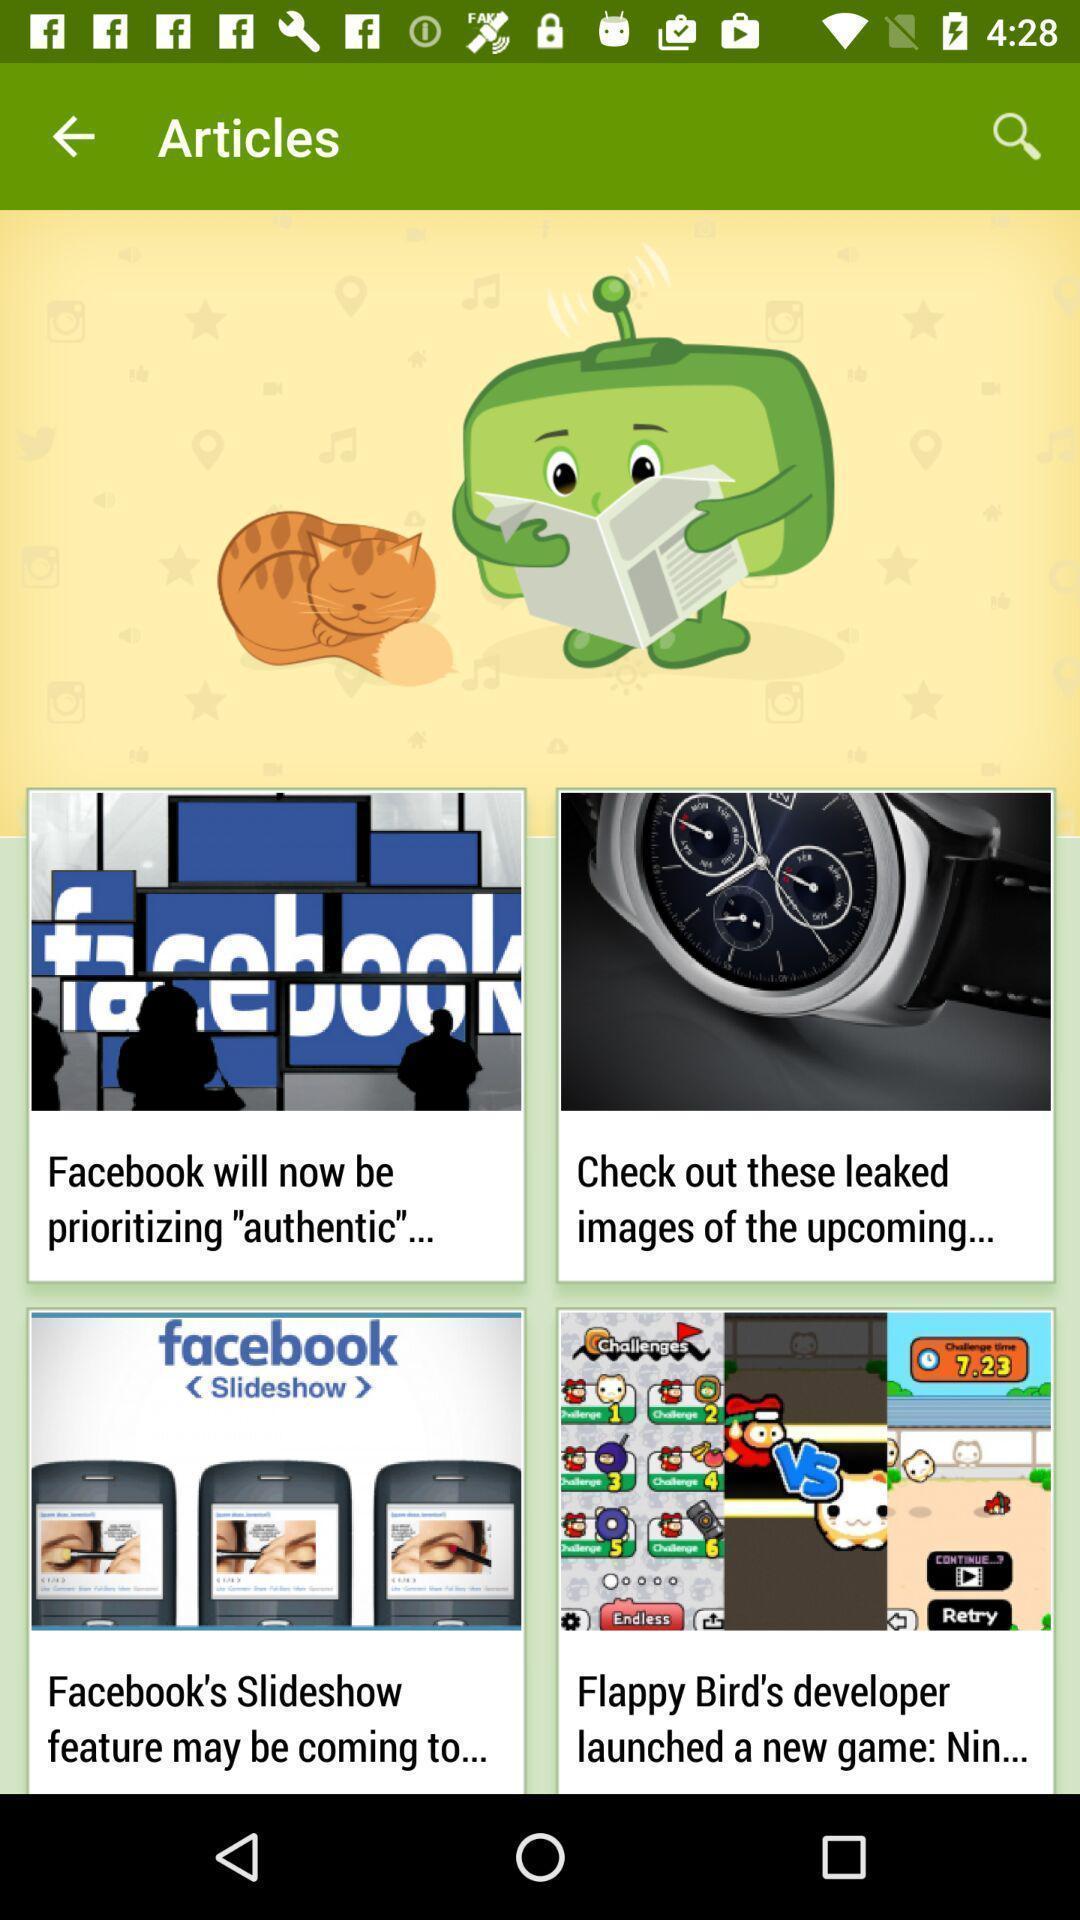Tell me what you see in this picture. Page with different articles on a local app. 